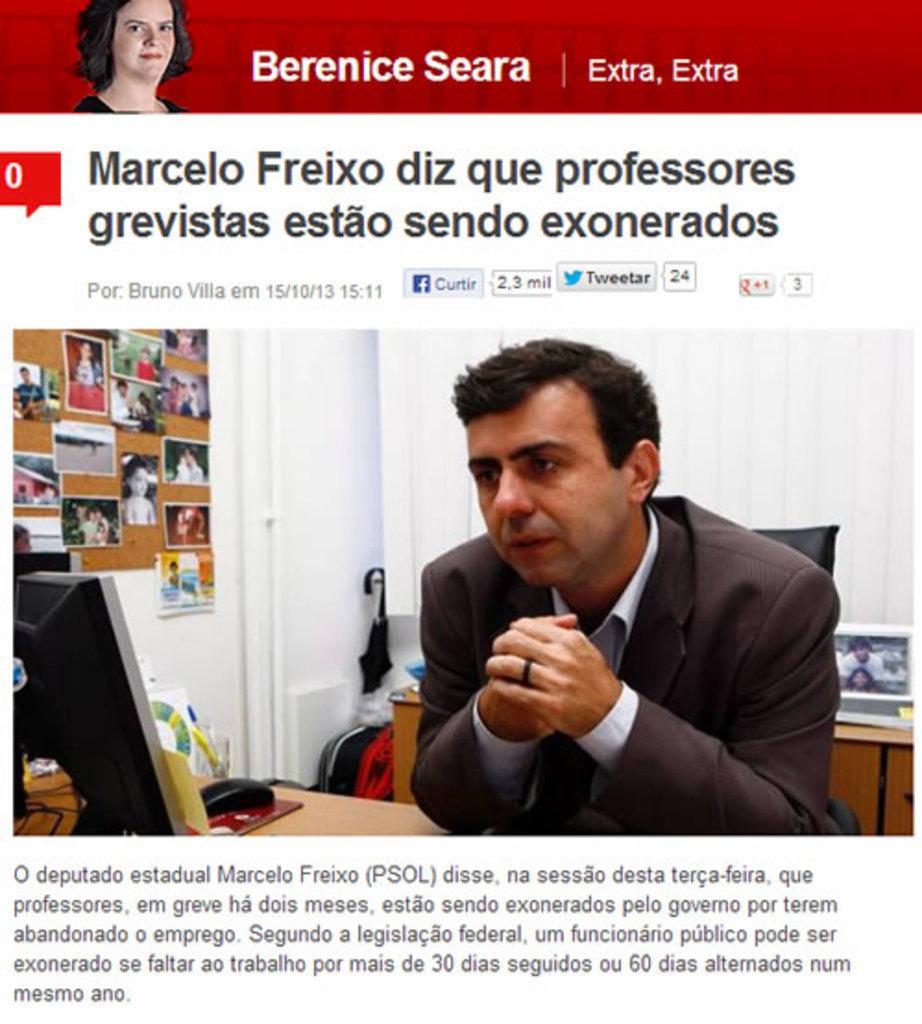Please provide a concise description of this image. This is an advertisement. In the center of the image we can see a man is sitting on a chair, in-front of him there is a table. On the table we can see a mouse, screen papers. In the background of the image we can see the photos, board, wall, photo frame and some other objects. At the top and bottom of the image we can see the text. At the top of the image we can see a lady and logo. 